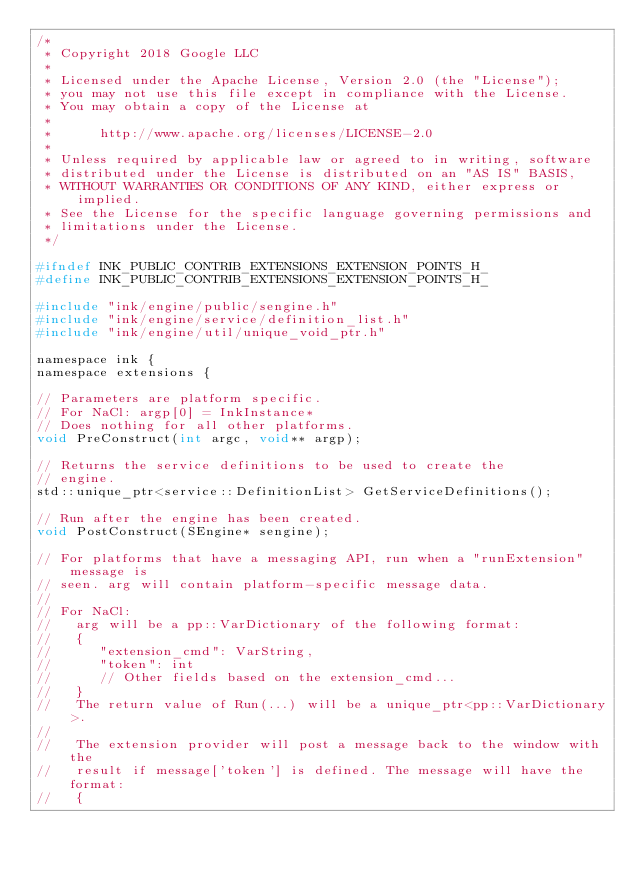<code> <loc_0><loc_0><loc_500><loc_500><_C_>/*
 * Copyright 2018 Google LLC
 *
 * Licensed under the Apache License, Version 2.0 (the "License");
 * you may not use this file except in compliance with the License.
 * You may obtain a copy of the License at
 *
 *      http://www.apache.org/licenses/LICENSE-2.0
 *
 * Unless required by applicable law or agreed to in writing, software
 * distributed under the License is distributed on an "AS IS" BASIS,
 * WITHOUT WARRANTIES OR CONDITIONS OF ANY KIND, either express or implied.
 * See the License for the specific language governing permissions and
 * limitations under the License.
 */

#ifndef INK_PUBLIC_CONTRIB_EXTENSIONS_EXTENSION_POINTS_H_
#define INK_PUBLIC_CONTRIB_EXTENSIONS_EXTENSION_POINTS_H_

#include "ink/engine/public/sengine.h"
#include "ink/engine/service/definition_list.h"
#include "ink/engine/util/unique_void_ptr.h"

namespace ink {
namespace extensions {

// Parameters are platform specific.
// For NaCl: argp[0] = InkInstance*
// Does nothing for all other platforms.
void PreConstruct(int argc, void** argp);

// Returns the service definitions to be used to create the
// engine.
std::unique_ptr<service::DefinitionList> GetServiceDefinitions();

// Run after the engine has been created.
void PostConstruct(SEngine* sengine);

// For platforms that have a messaging API, run when a "runExtension" message is
// seen. arg will contain platform-specific message data.
//
// For NaCl:
//   arg will be a pp::VarDictionary of the following format:
//   {
//      "extension_cmd": VarString,
//      "token": int
//      // Other fields based on the extension_cmd...
//   }
//   The return value of Run(...) will be a unique_ptr<pp::VarDictionary>.
//
//   The extension provider will post a message back to the window with the
//   result if message['token'] is defined. The message will have the format:
//   {</code> 